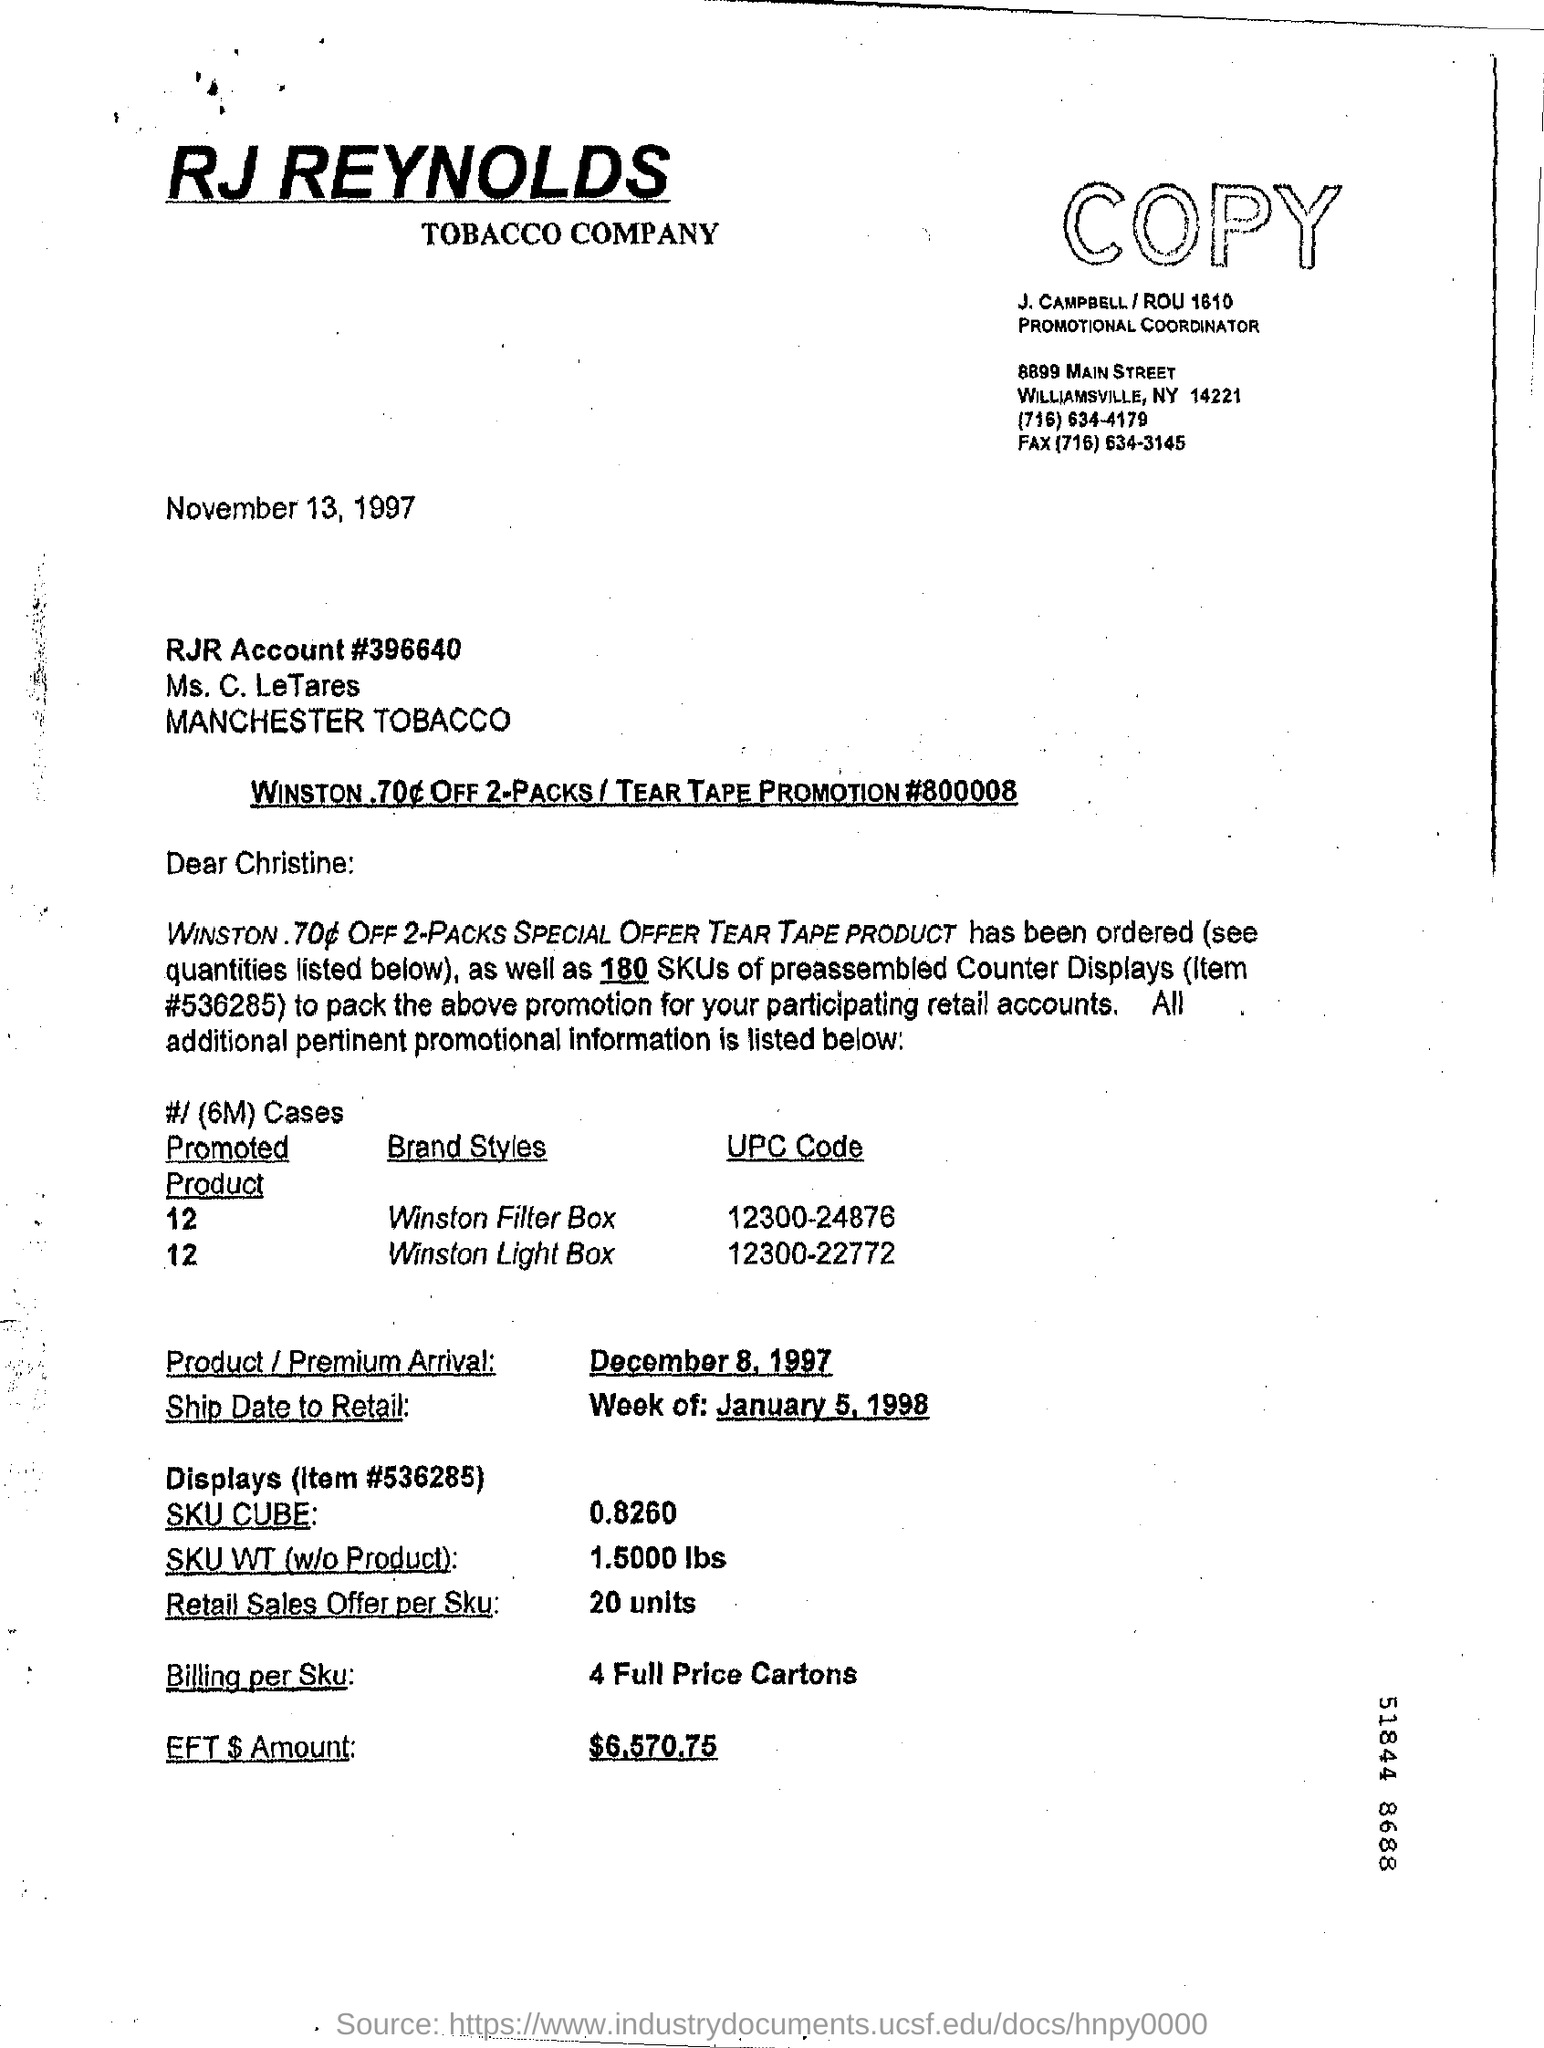What is the date on the document? The document is dated November 13, 1997. This was a Thursday during the late 1990s, reflective of a period when physical documents with typed correspondence were the norm for professional communication. 